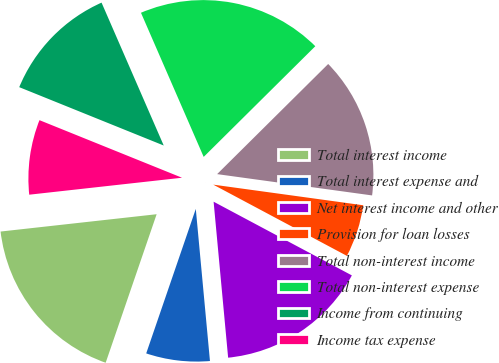Convert chart to OTSL. <chart><loc_0><loc_0><loc_500><loc_500><pie_chart><fcel>Total interest income<fcel>Total interest expense and<fcel>Net interest income and other<fcel>Provision for loan losses<fcel>Total non-interest income<fcel>Total non-interest expense<fcel>Income from continuing<fcel>Income tax expense<nl><fcel>17.98%<fcel>6.74%<fcel>15.73%<fcel>5.62%<fcel>14.61%<fcel>19.1%<fcel>12.36%<fcel>7.87%<nl></chart> 